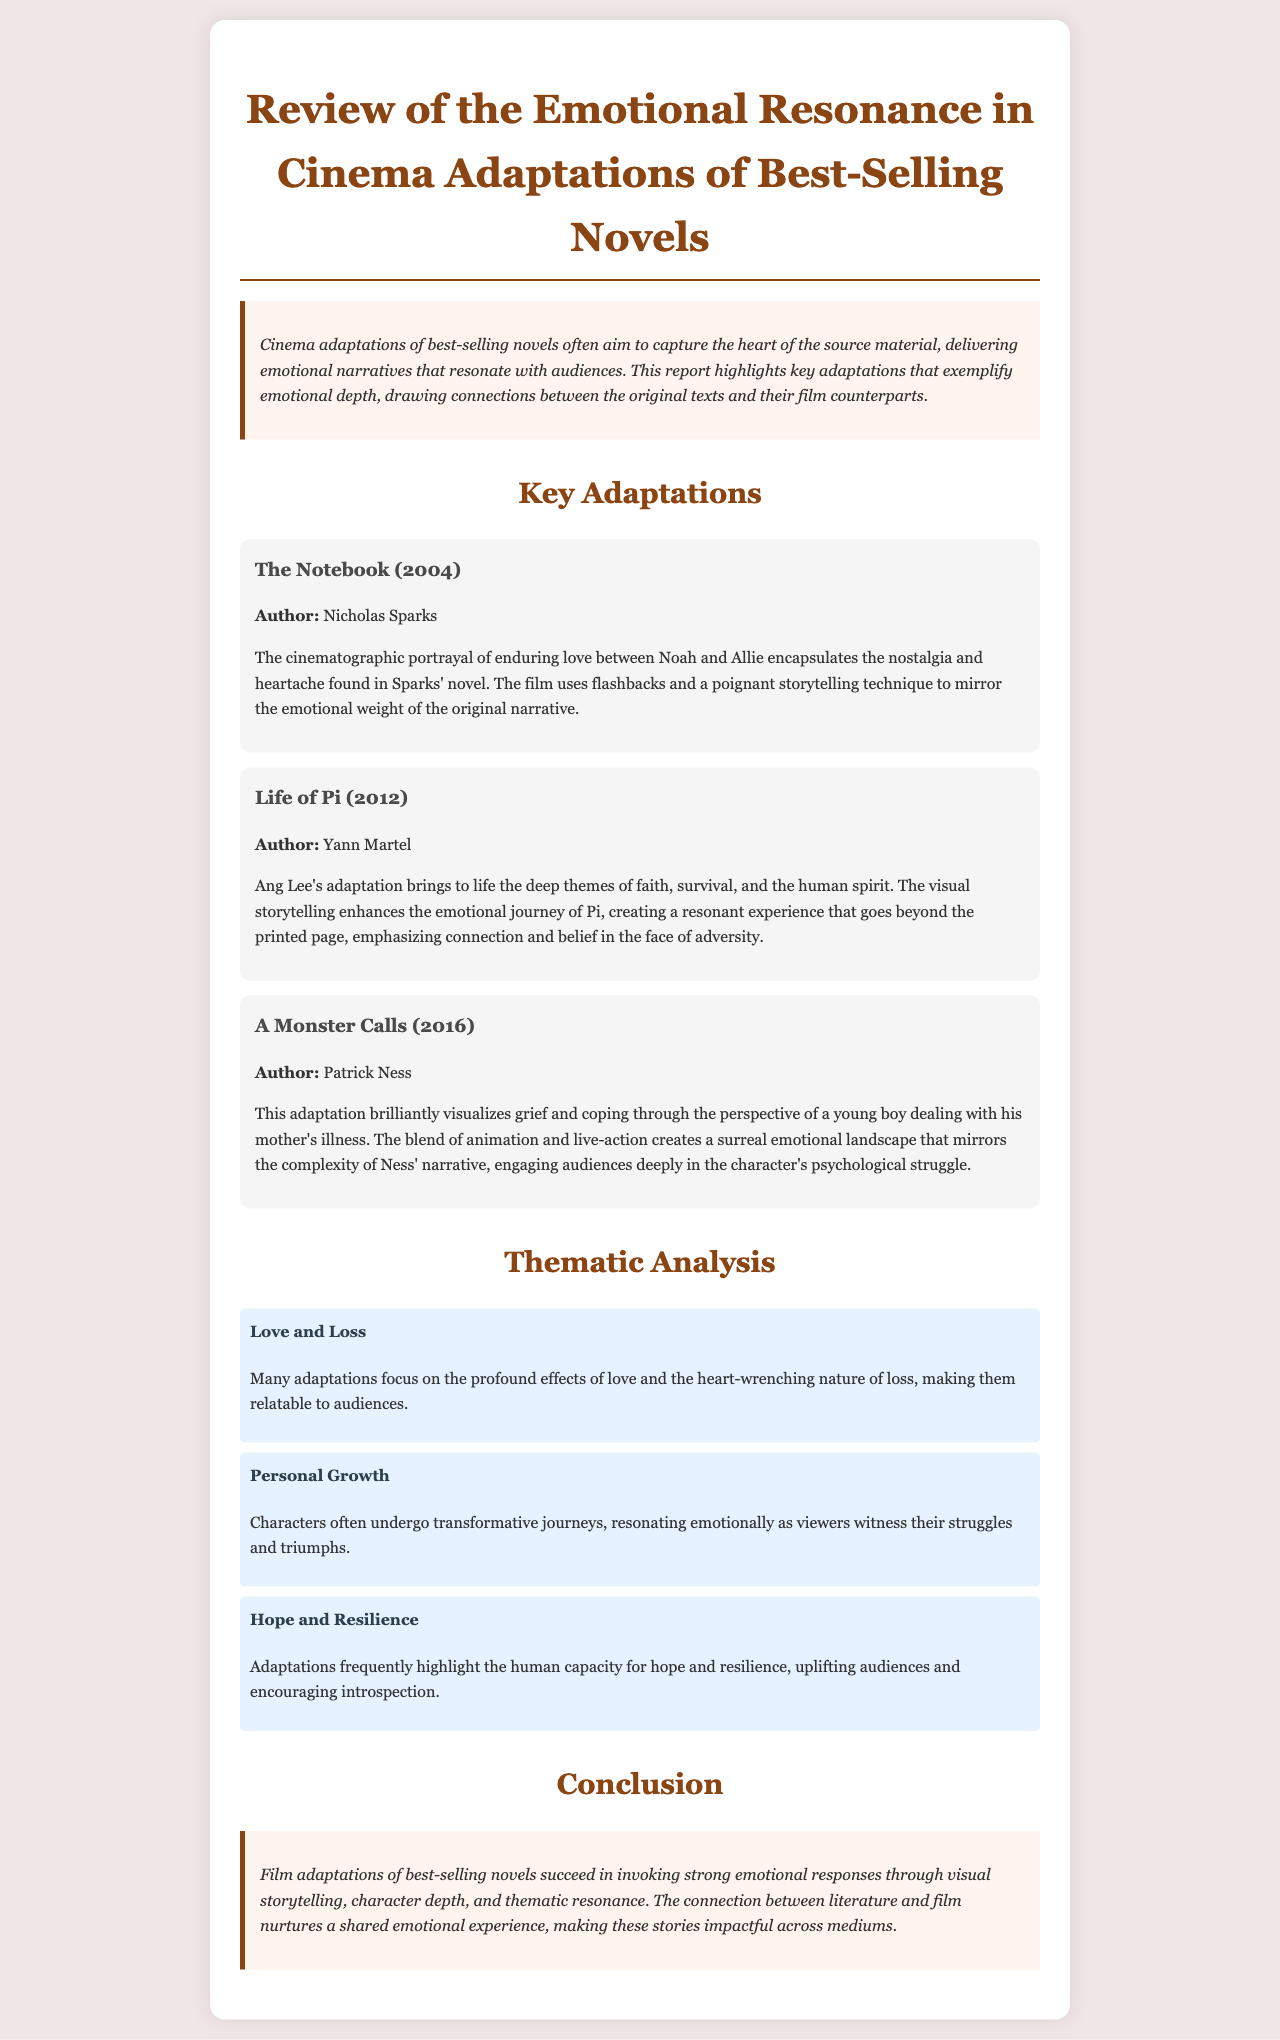what is the title of the report? The title of the report is stated in the heading.
Answer: Review of the Emotional Resonance in Cinema Adaptations of Best-Selling Novels who is the author of "The Notebook"? The author of "The Notebook" is mentioned in the adaptation section.
Answer: Nicholas Sparks what year was "Life of Pi" released? The release year of "Life of Pi" is listed in the adaptation section.
Answer: 2012 which adaptation focuses on a young boy dealing with his mother's illness? The adaptation prominently discussing this theme is identified in the adaptation section.
Answer: A Monster Calls what are the three themes analyzed in the document? The themes are highlighted in their respective sections.
Answer: Love and Loss, Personal Growth, Hope and Resilience how does the document describe film adaptations in the conclusion? The conclusion summarizes the emotional impact of film adaptations.
Answer: Invoking strong emotional responses what storytelling technique is used in "The Notebook"? A specific technique for storytelling in "The Notebook" is mentioned.
Answer: Flashbacks what is one of the emotional themes frequently highlighted in adaptations? The document mentions an emotional theme in the thematic analysis section.
Answer: Hope and Resilience 